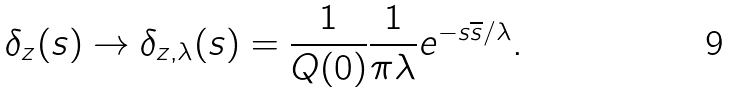Convert formula to latex. <formula><loc_0><loc_0><loc_500><loc_500>\delta _ { z } ( s ) \rightarrow \delta _ { z , \lambda } ( s ) = \frac { 1 } { Q ( 0 ) } \frac { 1 } { \pi \lambda } e ^ { - s \overline { s } / \lambda } .</formula> 